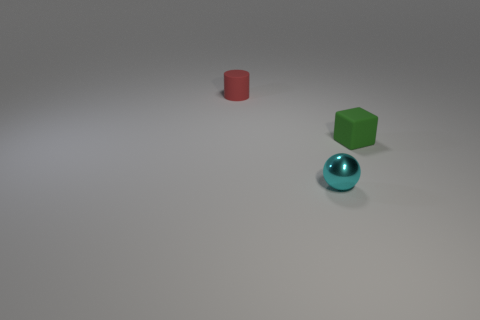Is there anything else that has the same material as the tiny cyan thing?
Provide a succinct answer. No. Do the tiny cyan object and the tiny thing behind the green block have the same material?
Ensure brevity in your answer.  No. There is a object that is right of the small metallic object; what is it made of?
Offer a very short reply. Rubber. Is the number of small red matte cylinders in front of the small red cylinder the same as the number of gray metallic balls?
Provide a succinct answer. Yes. Are there any other things that are the same size as the rubber cylinder?
Your answer should be compact. Yes. The thing that is in front of the object right of the tiny cyan sphere is made of what material?
Your response must be concise. Metal. What is the shape of the small thing that is behind the small shiny sphere and left of the small cube?
Make the answer very short. Cylinder. Are there fewer things behind the shiny sphere than things?
Your answer should be compact. Yes. What is the size of the matte object behind the block?
Keep it short and to the point. Small. What number of tiny rubber cubes have the same color as the small shiny sphere?
Your response must be concise. 0. 